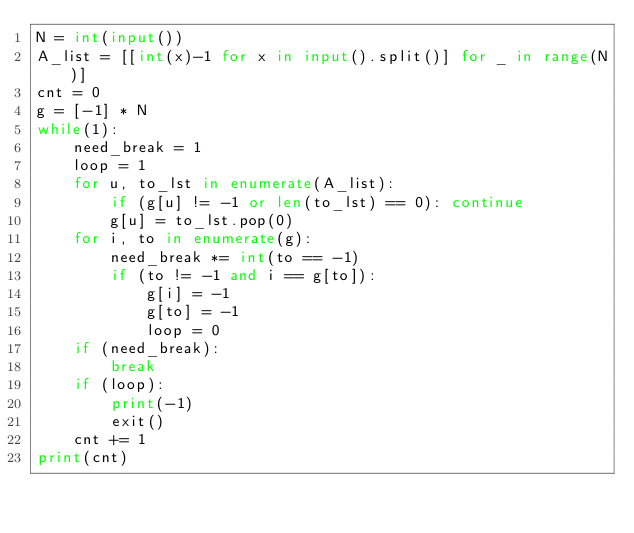Convert code to text. <code><loc_0><loc_0><loc_500><loc_500><_Python_>N = int(input())
A_list = [[int(x)-1 for x in input().split()] for _ in range(N)]
cnt = 0
g = [-1] * N
while(1):
    need_break = 1
    loop = 1
    for u, to_lst in enumerate(A_list):
        if (g[u] != -1 or len(to_lst) == 0): continue
        g[u] = to_lst.pop(0)
    for i, to in enumerate(g):
        need_break *= int(to == -1)
        if (to != -1 and i == g[to]):
            g[i] = -1
            g[to] = -1
            loop = 0
    if (need_break):
        break
    if (loop):
        print(-1)
        exit()
    cnt += 1
print(cnt)        
</code> 